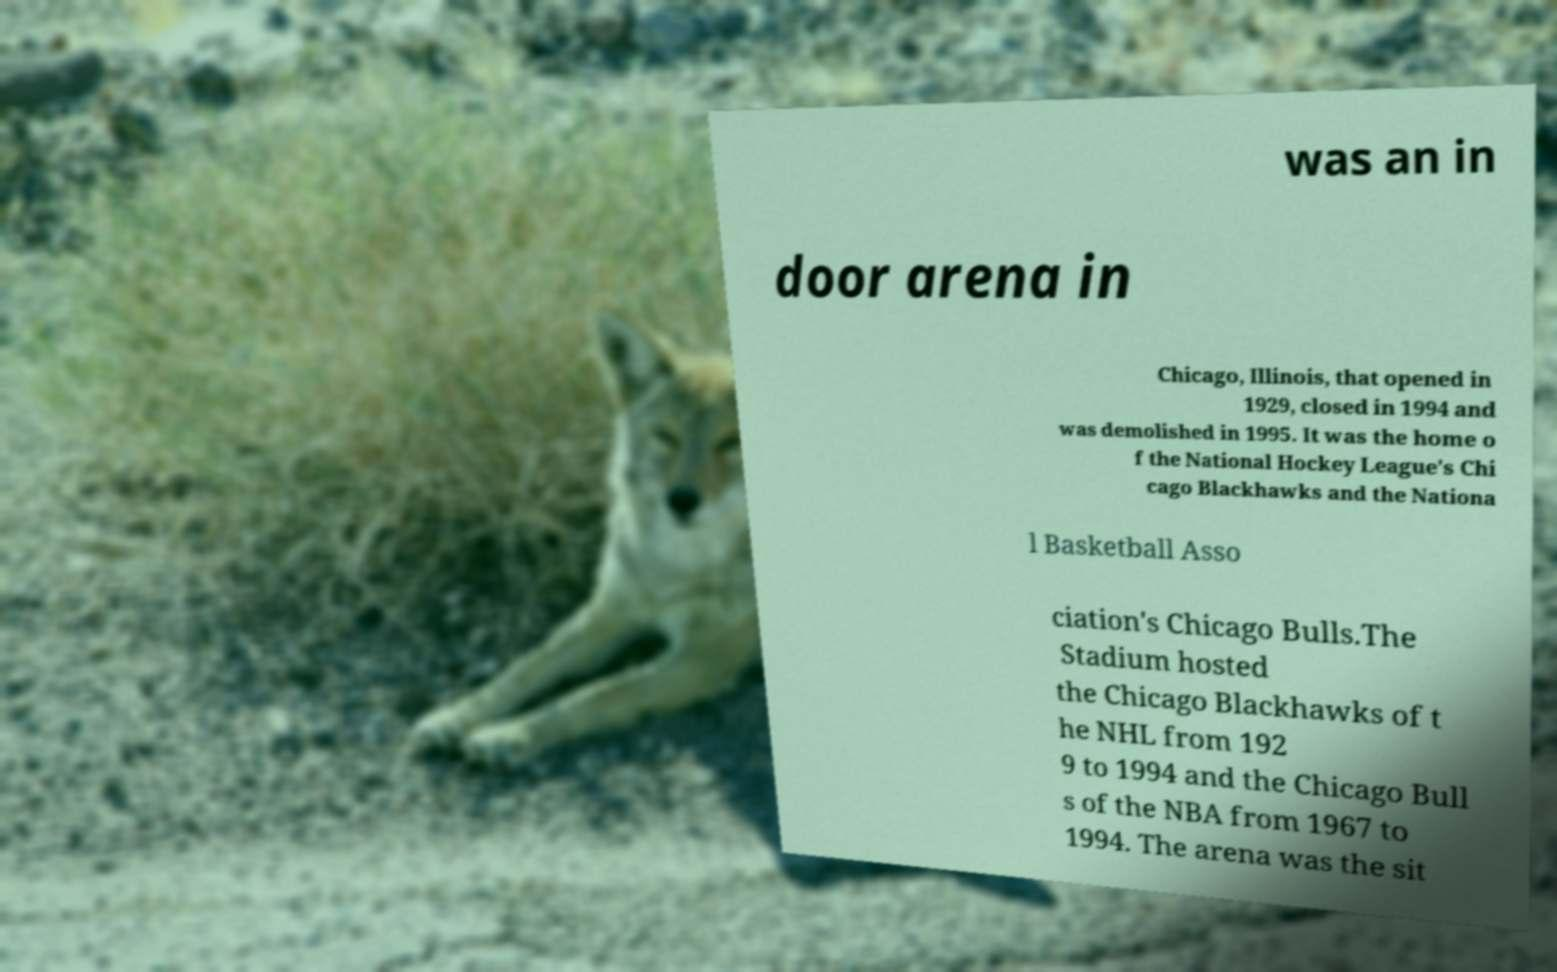Can you accurately transcribe the text from the provided image for me? was an in door arena in Chicago, Illinois, that opened in 1929, closed in 1994 and was demolished in 1995. It was the home o f the National Hockey League's Chi cago Blackhawks and the Nationa l Basketball Asso ciation's Chicago Bulls.The Stadium hosted the Chicago Blackhawks of t he NHL from 192 9 to 1994 and the Chicago Bull s of the NBA from 1967 to 1994. The arena was the sit 